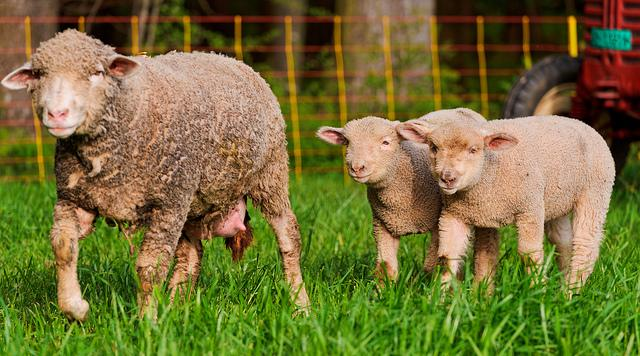How many lambs are lead by this sheep? Please explain your reasoning. two. There are less than three lambs but more than one lamb visible in the image. 